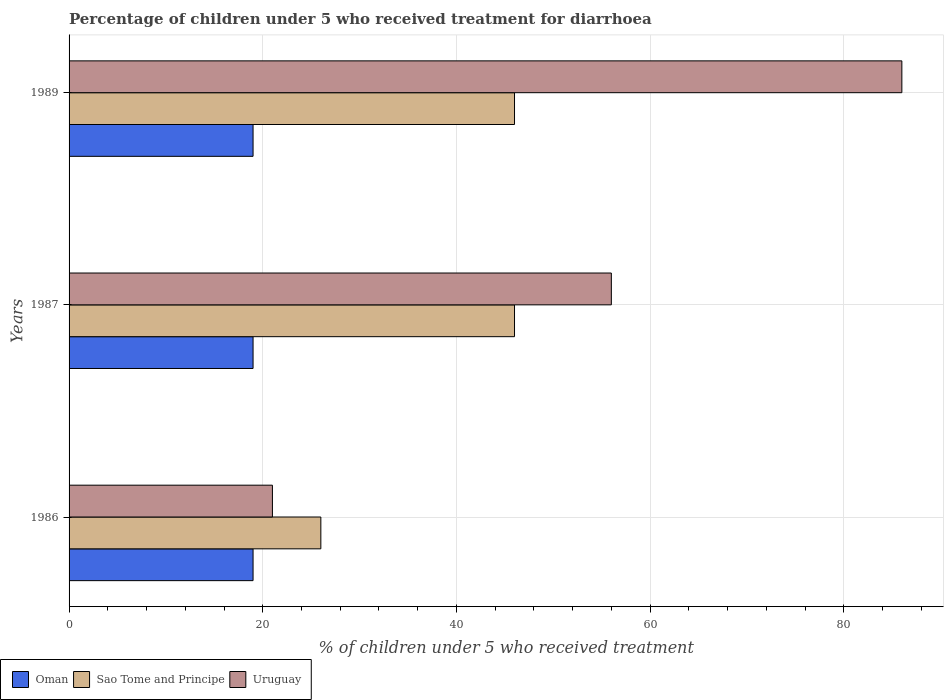How many different coloured bars are there?
Your response must be concise. 3. How many bars are there on the 1st tick from the top?
Your answer should be very brief. 3. In how many cases, is the number of bars for a given year not equal to the number of legend labels?
Your answer should be compact. 0. What is the percentage of children who received treatment for diarrhoea  in Sao Tome and Principe in 1989?
Your answer should be very brief. 46. In which year was the percentage of children who received treatment for diarrhoea  in Uruguay minimum?
Your response must be concise. 1986. What is the total percentage of children who received treatment for diarrhoea  in Oman in the graph?
Provide a succinct answer. 57. What is the average percentage of children who received treatment for diarrhoea  in Sao Tome and Principe per year?
Make the answer very short. 39.33. In how many years, is the percentage of children who received treatment for diarrhoea  in Sao Tome and Principe greater than 72 %?
Provide a short and direct response. 0. What is the ratio of the percentage of children who received treatment for diarrhoea  in Oman in 1986 to that in 1989?
Provide a succinct answer. 1. What is the difference between the highest and the lowest percentage of children who received treatment for diarrhoea  in Sao Tome and Principe?
Provide a succinct answer. 20. In how many years, is the percentage of children who received treatment for diarrhoea  in Sao Tome and Principe greater than the average percentage of children who received treatment for diarrhoea  in Sao Tome and Principe taken over all years?
Ensure brevity in your answer.  2. Is the sum of the percentage of children who received treatment for diarrhoea  in Sao Tome and Principe in 1986 and 1987 greater than the maximum percentage of children who received treatment for diarrhoea  in Oman across all years?
Ensure brevity in your answer.  Yes. What does the 3rd bar from the top in 1986 represents?
Offer a terse response. Oman. What does the 1st bar from the bottom in 1986 represents?
Offer a terse response. Oman. How many bars are there?
Provide a succinct answer. 9. Are all the bars in the graph horizontal?
Your answer should be compact. Yes. What is the difference between two consecutive major ticks on the X-axis?
Your answer should be compact. 20. Are the values on the major ticks of X-axis written in scientific E-notation?
Offer a very short reply. No. Does the graph contain any zero values?
Provide a short and direct response. No. How many legend labels are there?
Make the answer very short. 3. What is the title of the graph?
Offer a terse response. Percentage of children under 5 who received treatment for diarrhoea. Does "Bahrain" appear as one of the legend labels in the graph?
Ensure brevity in your answer.  No. What is the label or title of the X-axis?
Make the answer very short. % of children under 5 who received treatment. What is the label or title of the Y-axis?
Your answer should be very brief. Years. What is the % of children under 5 who received treatment of Sao Tome and Principe in 1986?
Ensure brevity in your answer.  26. What is the % of children under 5 who received treatment in Oman in 1987?
Offer a very short reply. 19. What is the % of children under 5 who received treatment of Uruguay in 1987?
Keep it short and to the point. 56. What is the % of children under 5 who received treatment of Uruguay in 1989?
Ensure brevity in your answer.  86. Across all years, what is the maximum % of children under 5 who received treatment in Oman?
Provide a succinct answer. 19. Across all years, what is the maximum % of children under 5 who received treatment in Uruguay?
Your answer should be very brief. 86. Across all years, what is the minimum % of children under 5 who received treatment of Oman?
Offer a terse response. 19. What is the total % of children under 5 who received treatment in Oman in the graph?
Give a very brief answer. 57. What is the total % of children under 5 who received treatment of Sao Tome and Principe in the graph?
Your response must be concise. 118. What is the total % of children under 5 who received treatment in Uruguay in the graph?
Your answer should be very brief. 163. What is the difference between the % of children under 5 who received treatment in Oman in 1986 and that in 1987?
Your response must be concise. 0. What is the difference between the % of children under 5 who received treatment in Sao Tome and Principe in 1986 and that in 1987?
Your answer should be compact. -20. What is the difference between the % of children under 5 who received treatment of Uruguay in 1986 and that in 1987?
Your answer should be very brief. -35. What is the difference between the % of children under 5 who received treatment of Sao Tome and Principe in 1986 and that in 1989?
Your response must be concise. -20. What is the difference between the % of children under 5 who received treatment in Uruguay in 1986 and that in 1989?
Your answer should be very brief. -65. What is the difference between the % of children under 5 who received treatment of Oman in 1987 and that in 1989?
Your response must be concise. 0. What is the difference between the % of children under 5 who received treatment in Sao Tome and Principe in 1987 and that in 1989?
Offer a terse response. 0. What is the difference between the % of children under 5 who received treatment in Oman in 1986 and the % of children under 5 who received treatment in Sao Tome and Principe in 1987?
Your answer should be compact. -27. What is the difference between the % of children under 5 who received treatment in Oman in 1986 and the % of children under 5 who received treatment in Uruguay in 1987?
Offer a terse response. -37. What is the difference between the % of children under 5 who received treatment in Oman in 1986 and the % of children under 5 who received treatment in Uruguay in 1989?
Your answer should be very brief. -67. What is the difference between the % of children under 5 who received treatment in Sao Tome and Principe in 1986 and the % of children under 5 who received treatment in Uruguay in 1989?
Provide a succinct answer. -60. What is the difference between the % of children under 5 who received treatment in Oman in 1987 and the % of children under 5 who received treatment in Sao Tome and Principe in 1989?
Ensure brevity in your answer.  -27. What is the difference between the % of children under 5 who received treatment of Oman in 1987 and the % of children under 5 who received treatment of Uruguay in 1989?
Offer a terse response. -67. What is the average % of children under 5 who received treatment of Sao Tome and Principe per year?
Make the answer very short. 39.33. What is the average % of children under 5 who received treatment of Uruguay per year?
Offer a terse response. 54.33. In the year 1986, what is the difference between the % of children under 5 who received treatment in Oman and % of children under 5 who received treatment in Sao Tome and Principe?
Keep it short and to the point. -7. In the year 1986, what is the difference between the % of children under 5 who received treatment of Sao Tome and Principe and % of children under 5 who received treatment of Uruguay?
Make the answer very short. 5. In the year 1987, what is the difference between the % of children under 5 who received treatment in Oman and % of children under 5 who received treatment in Uruguay?
Provide a short and direct response. -37. In the year 1989, what is the difference between the % of children under 5 who received treatment in Oman and % of children under 5 who received treatment in Uruguay?
Offer a terse response. -67. In the year 1989, what is the difference between the % of children under 5 who received treatment of Sao Tome and Principe and % of children under 5 who received treatment of Uruguay?
Your response must be concise. -40. What is the ratio of the % of children under 5 who received treatment of Oman in 1986 to that in 1987?
Provide a succinct answer. 1. What is the ratio of the % of children under 5 who received treatment in Sao Tome and Principe in 1986 to that in 1987?
Ensure brevity in your answer.  0.57. What is the ratio of the % of children under 5 who received treatment in Uruguay in 1986 to that in 1987?
Offer a terse response. 0.38. What is the ratio of the % of children under 5 who received treatment in Sao Tome and Principe in 1986 to that in 1989?
Your answer should be compact. 0.57. What is the ratio of the % of children under 5 who received treatment in Uruguay in 1986 to that in 1989?
Offer a very short reply. 0.24. What is the ratio of the % of children under 5 who received treatment in Sao Tome and Principe in 1987 to that in 1989?
Your answer should be very brief. 1. What is the ratio of the % of children under 5 who received treatment in Uruguay in 1987 to that in 1989?
Provide a succinct answer. 0.65. What is the difference between the highest and the second highest % of children under 5 who received treatment of Oman?
Offer a very short reply. 0. What is the difference between the highest and the second highest % of children under 5 who received treatment of Sao Tome and Principe?
Offer a very short reply. 0. What is the difference between the highest and the second highest % of children under 5 who received treatment of Uruguay?
Offer a terse response. 30. What is the difference between the highest and the lowest % of children under 5 who received treatment in Sao Tome and Principe?
Offer a terse response. 20. What is the difference between the highest and the lowest % of children under 5 who received treatment of Uruguay?
Provide a succinct answer. 65. 